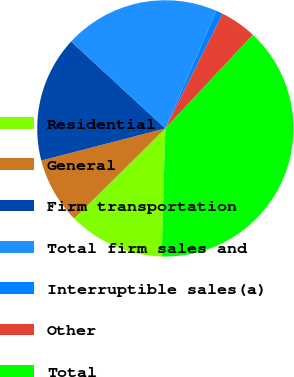Convert chart. <chart><loc_0><loc_0><loc_500><loc_500><pie_chart><fcel>Residential<fcel>General<fcel>Firm transportation<fcel>Total firm sales and<fcel>Interruptible sales(a)<fcel>Other<fcel>Total<nl><fcel>12.13%<fcel>8.37%<fcel>15.9%<fcel>19.66%<fcel>0.84%<fcel>4.61%<fcel>38.49%<nl></chart> 